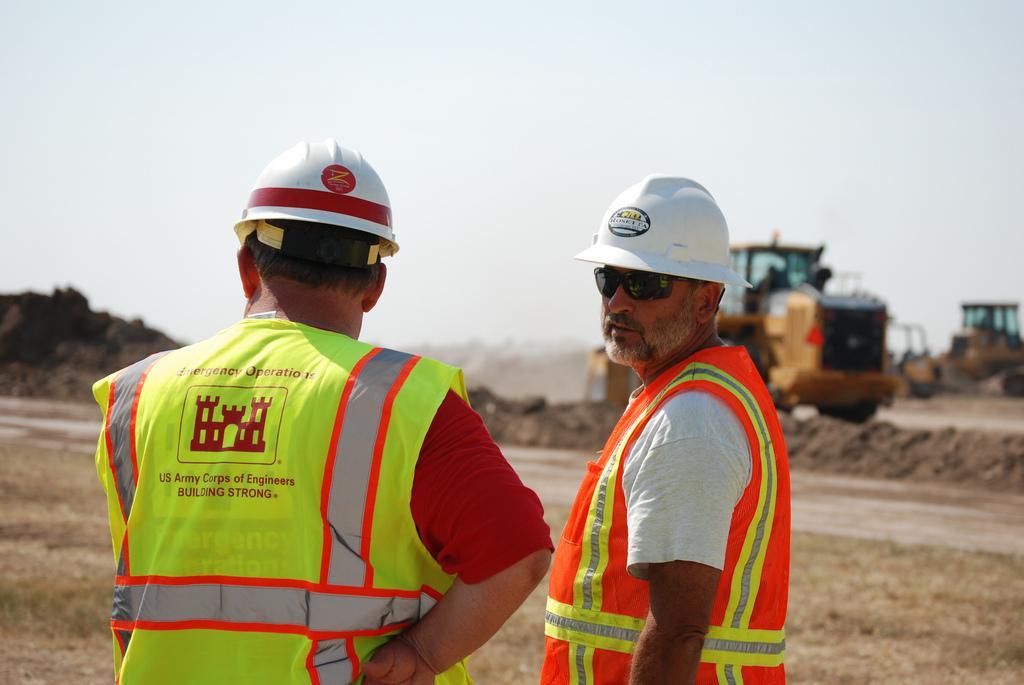Describe this image in one or two sentences. In this image I can see 2 people standing and wearing white helmets and they are wearing uniform. There are vehicles at the back and there is sky at the top. 